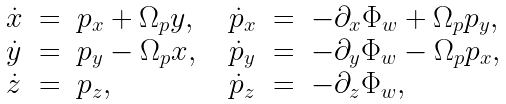<formula> <loc_0><loc_0><loc_500><loc_500>\begin{array} { l c l c l c l } \dot { x } & = & p _ { x } + \Omega _ { p } y , & & \dot { p } _ { x } & = & - \partial _ { x } \Phi _ { w } + \Omega _ { p } p _ { y } , \\ \dot { y } & = & p _ { y } - \Omega _ { p } x , & & \dot { p } _ { y } & = & - \partial _ { y } \Phi _ { w } - \Omega _ { p } p _ { x } , \\ \dot { z } & = & p _ { z } , & & \dot { p } _ { z } & = & - \partial _ { z } \Phi _ { w } , \end{array}</formula> 